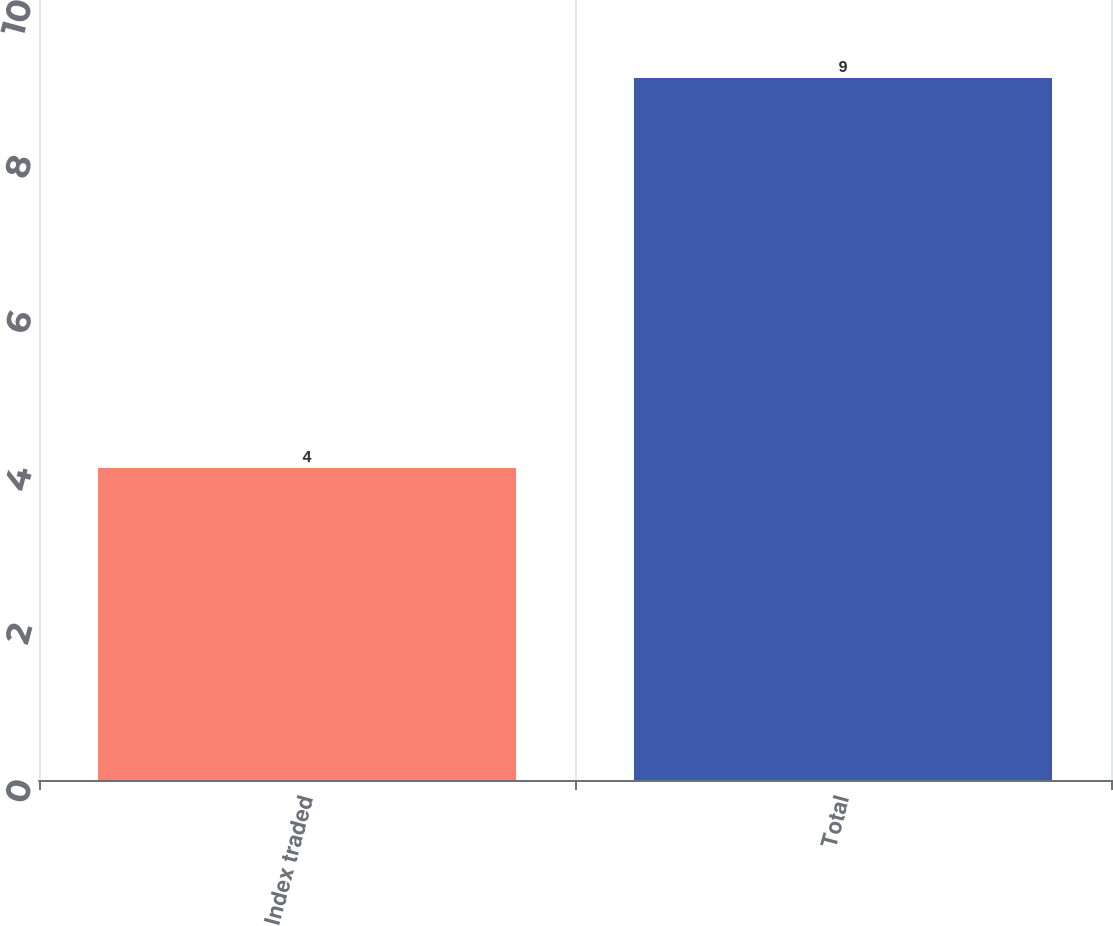<chart> <loc_0><loc_0><loc_500><loc_500><bar_chart><fcel>Index traded<fcel>Total<nl><fcel>4<fcel>9<nl></chart> 